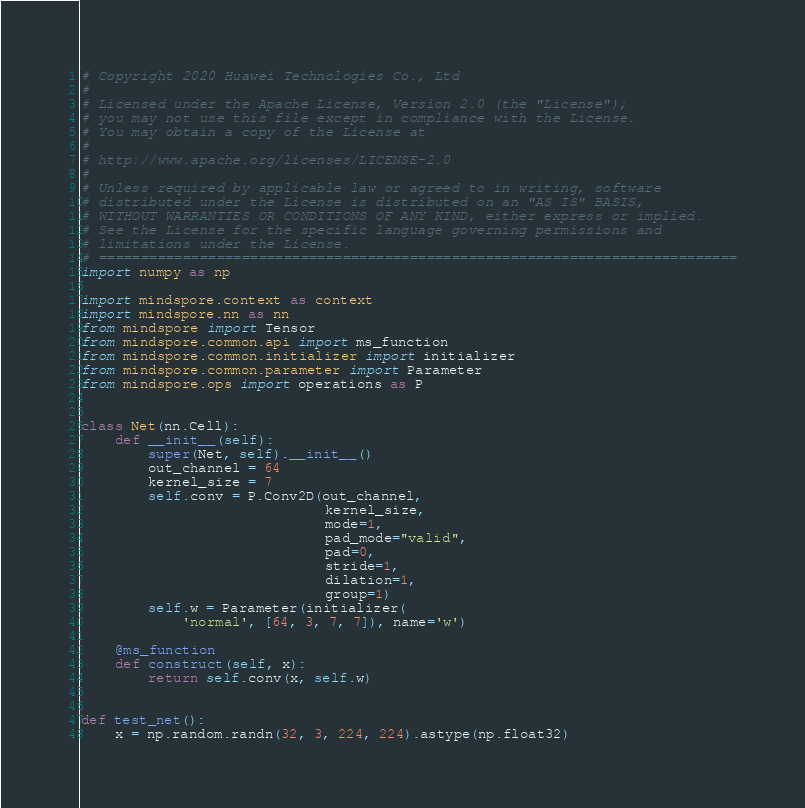<code> <loc_0><loc_0><loc_500><loc_500><_Python_># Copyright 2020 Huawei Technologies Co., Ltd
#
# Licensed under the Apache License, Version 2.0 (the "License");
# you may not use this file except in compliance with the License.
# You may obtain a copy of the License at
#
# http://www.apache.org/licenses/LICENSE-2.0
#
# Unless required by applicable law or agreed to in writing, software
# distributed under the License is distributed on an "AS IS" BASIS,
# WITHOUT WARRANTIES OR CONDITIONS OF ANY KIND, either express or implied.
# See the License for the specific language governing permissions and
# limitations under the License.
# ============================================================================
import numpy as np

import mindspore.context as context
import mindspore.nn as nn
from mindspore import Tensor
from mindspore.common.api import ms_function
from mindspore.common.initializer import initializer
from mindspore.common.parameter import Parameter
from mindspore.ops import operations as P


class Net(nn.Cell):
    def __init__(self):
        super(Net, self).__init__()
        out_channel = 64
        kernel_size = 7
        self.conv = P.Conv2D(out_channel,
                             kernel_size,
                             mode=1,
                             pad_mode="valid",
                             pad=0,
                             stride=1,
                             dilation=1,
                             group=1)
        self.w = Parameter(initializer(
            'normal', [64, 3, 7, 7]), name='w')

    @ms_function
    def construct(self, x):
        return self.conv(x, self.w)


def test_net():
    x = np.random.randn(32, 3, 224, 224).astype(np.float32)</code> 